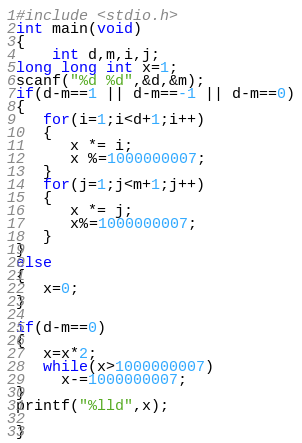Convert code to text. <code><loc_0><loc_0><loc_500><loc_500><_C_>#include <stdio.h>
int main(void)
{
    int d,m,i,j;
long long int x=1;
scanf("%d %d",&d,&m);
if(d-m==1 || d-m==-1 || d-m==0)
{
   for(i=1;i<d+1;i++)
   {
      x *= i;
      x %=1000000007;
   }
   for(j=1;j<m+1;j++)
   {
      x *= j;
      x%=1000000007;
   }
}
else
{
   x=0;
}
 
if(d-m==0)
{
   x=x*2;
   while(x>1000000007)
     x-=1000000007;
}
printf("%lld",x);
 
}</code> 